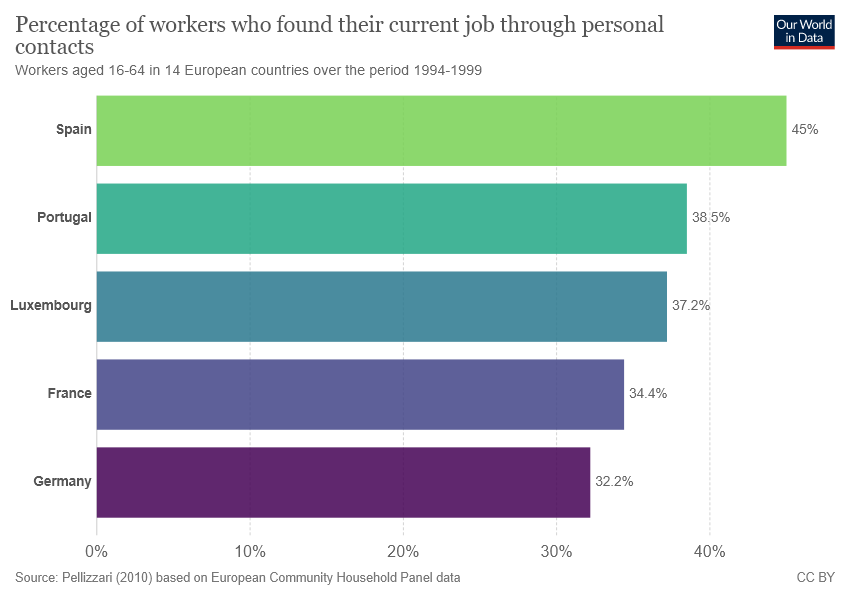Outline some significant characteristics in this image. The sum of the lowest two bars is 66.6..... Germany is commonly represented by the color purple. 